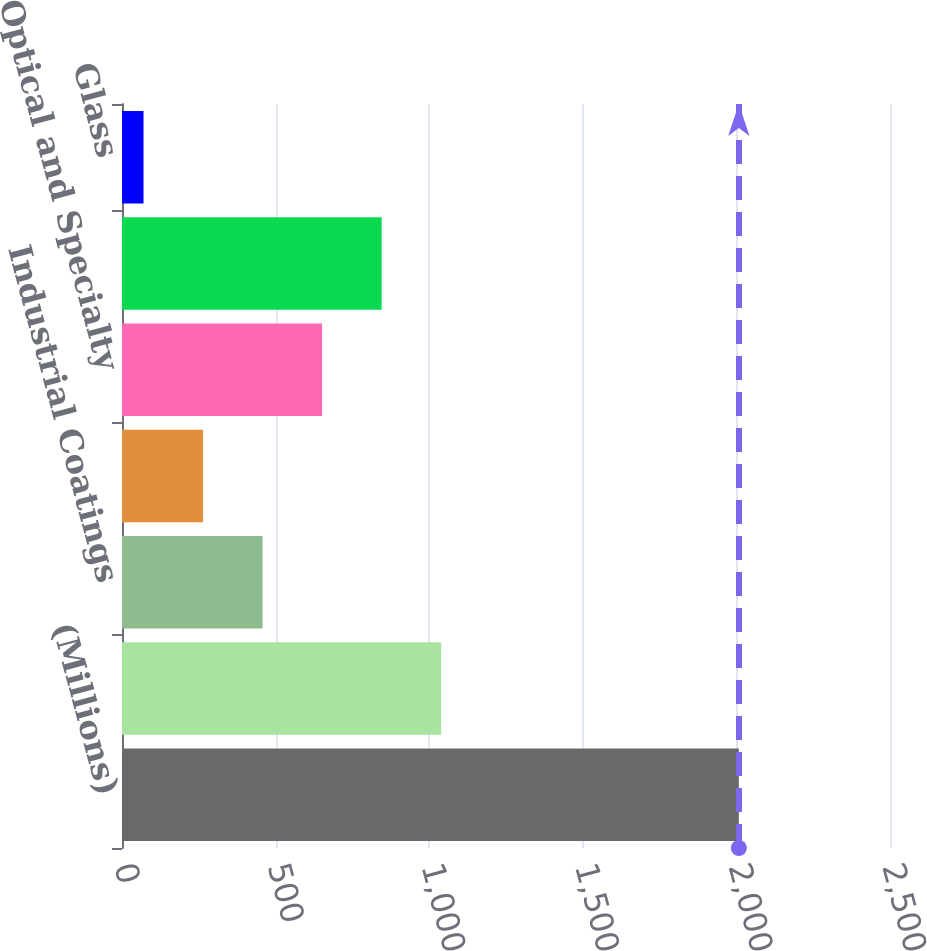Convert chart to OTSL. <chart><loc_0><loc_0><loc_500><loc_500><bar_chart><fcel>(Millions)<fcel>Performance Coatings<fcel>Industrial Coatings<fcel>Architectural Coatings - EMEA<fcel>Optical and Specialty<fcel>Commodity Chemicals<fcel>Glass<nl><fcel>2008<fcel>1039<fcel>457.6<fcel>263.8<fcel>651.4<fcel>845.2<fcel>70<nl></chart> 